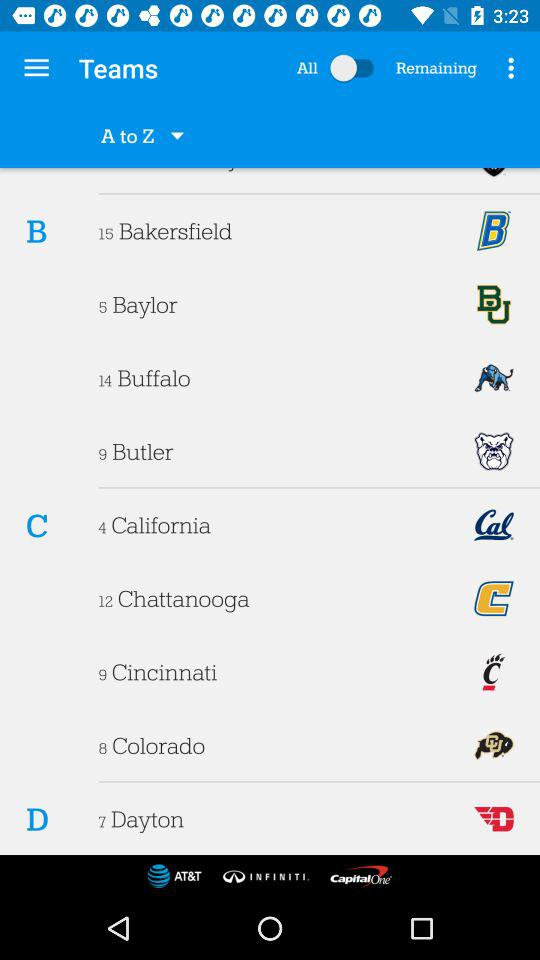What is the status of "All"? The status is "off". 